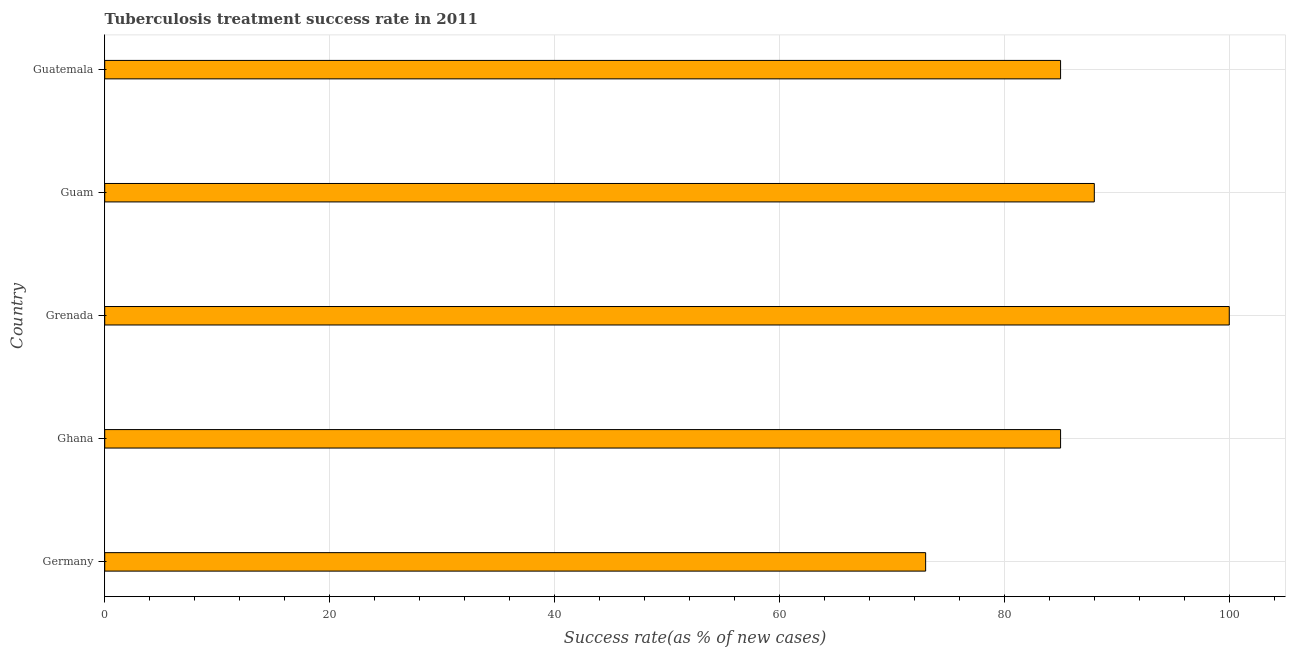Does the graph contain any zero values?
Make the answer very short. No. What is the title of the graph?
Offer a terse response. Tuberculosis treatment success rate in 2011. What is the label or title of the X-axis?
Keep it short and to the point. Success rate(as % of new cases). Across all countries, what is the maximum tuberculosis treatment success rate?
Provide a short and direct response. 100. Across all countries, what is the minimum tuberculosis treatment success rate?
Your response must be concise. 73. In which country was the tuberculosis treatment success rate maximum?
Give a very brief answer. Grenada. In which country was the tuberculosis treatment success rate minimum?
Ensure brevity in your answer.  Germany. What is the sum of the tuberculosis treatment success rate?
Offer a very short reply. 431. What is the average tuberculosis treatment success rate per country?
Provide a succinct answer. 86. What is the median tuberculosis treatment success rate?
Give a very brief answer. 85. What is the ratio of the tuberculosis treatment success rate in Germany to that in Ghana?
Ensure brevity in your answer.  0.86. Is the tuberculosis treatment success rate in Germany less than that in Ghana?
Your answer should be very brief. Yes. Is the sum of the tuberculosis treatment success rate in Germany and Guatemala greater than the maximum tuberculosis treatment success rate across all countries?
Ensure brevity in your answer.  Yes. How many bars are there?
Offer a terse response. 5. Are all the bars in the graph horizontal?
Keep it short and to the point. Yes. How many countries are there in the graph?
Provide a succinct answer. 5. What is the difference between two consecutive major ticks on the X-axis?
Make the answer very short. 20. Are the values on the major ticks of X-axis written in scientific E-notation?
Your answer should be compact. No. What is the Success rate(as % of new cases) of Germany?
Your answer should be very brief. 73. What is the Success rate(as % of new cases) of Grenada?
Your answer should be very brief. 100. What is the difference between the Success rate(as % of new cases) in Germany and Ghana?
Offer a terse response. -12. What is the difference between the Success rate(as % of new cases) in Germany and Grenada?
Provide a succinct answer. -27. What is the difference between the Success rate(as % of new cases) in Ghana and Guatemala?
Provide a short and direct response. 0. What is the difference between the Success rate(as % of new cases) in Grenada and Guatemala?
Keep it short and to the point. 15. What is the ratio of the Success rate(as % of new cases) in Germany to that in Ghana?
Provide a succinct answer. 0.86. What is the ratio of the Success rate(as % of new cases) in Germany to that in Grenada?
Offer a terse response. 0.73. What is the ratio of the Success rate(as % of new cases) in Germany to that in Guam?
Ensure brevity in your answer.  0.83. What is the ratio of the Success rate(as % of new cases) in Germany to that in Guatemala?
Keep it short and to the point. 0.86. What is the ratio of the Success rate(as % of new cases) in Grenada to that in Guam?
Offer a terse response. 1.14. What is the ratio of the Success rate(as % of new cases) in Grenada to that in Guatemala?
Make the answer very short. 1.18. What is the ratio of the Success rate(as % of new cases) in Guam to that in Guatemala?
Keep it short and to the point. 1.03. 